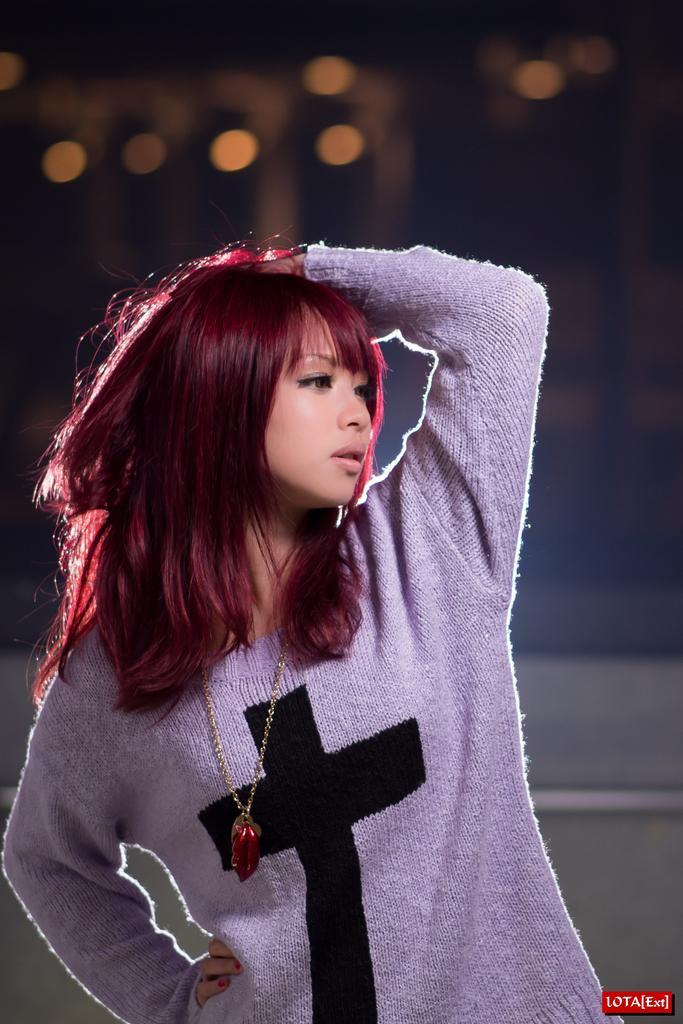In one or two sentences, can you explain what this image depicts? In this image we can see a woman wearing a chain. At the bottom we can see some text. In the background, we can see some lights. 